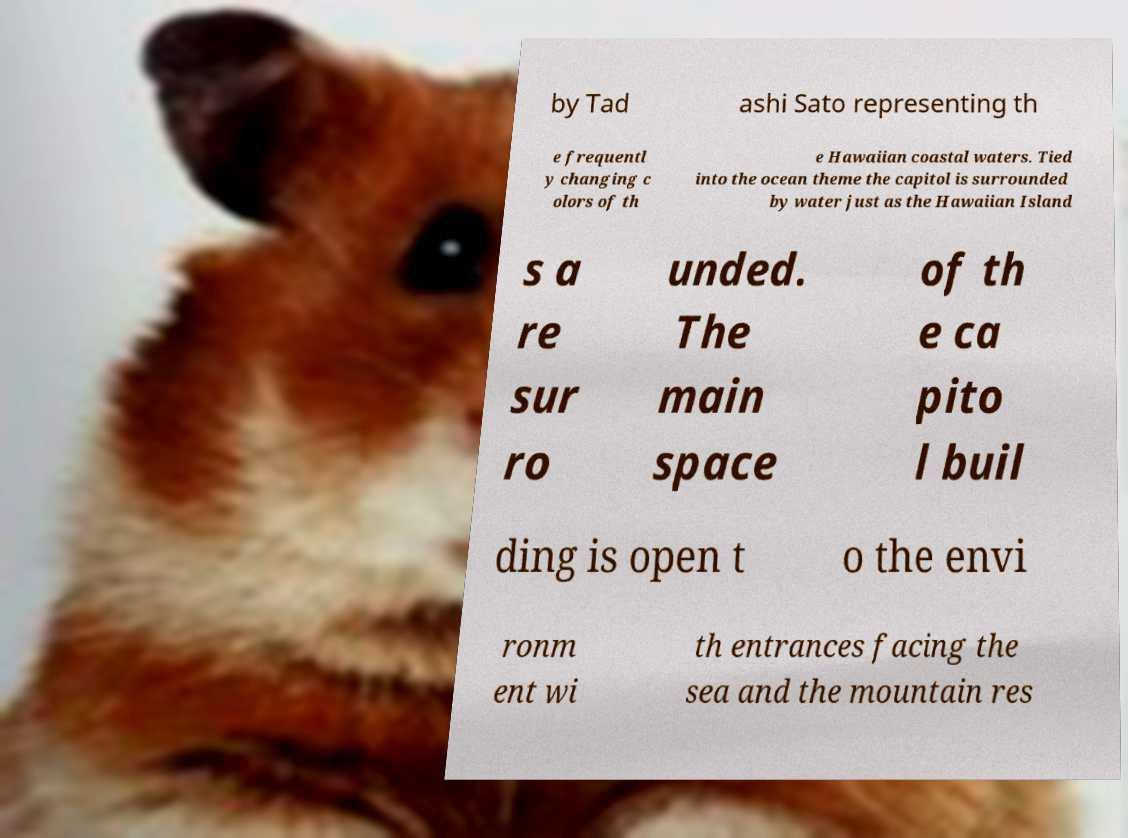Could you extract and type out the text from this image? by Tad ashi Sato representing th e frequentl y changing c olors of th e Hawaiian coastal waters. Tied into the ocean theme the capitol is surrounded by water just as the Hawaiian Island s a re sur ro unded. The main space of th e ca pito l buil ding is open t o the envi ronm ent wi th entrances facing the sea and the mountain res 